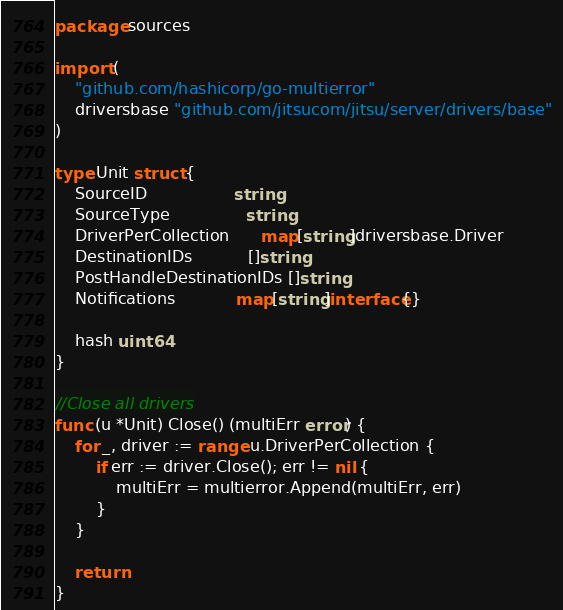<code> <loc_0><loc_0><loc_500><loc_500><_Go_>package sources

import (
	"github.com/hashicorp/go-multierror"
	driversbase "github.com/jitsucom/jitsu/server/drivers/base"
)

type Unit struct {
	SourceID                 string
	SourceType               string
	DriverPerCollection      map[string]driversbase.Driver
	DestinationIDs           []string
	PostHandleDestinationIDs []string
	Notifications            map[string]interface{}

	hash uint64
}

//Close all drivers
func (u *Unit) Close() (multiErr error) {
	for _, driver := range u.DriverPerCollection {
		if err := driver.Close(); err != nil {
			multiErr = multierror.Append(multiErr, err)
		}
	}

	return
}
</code> 